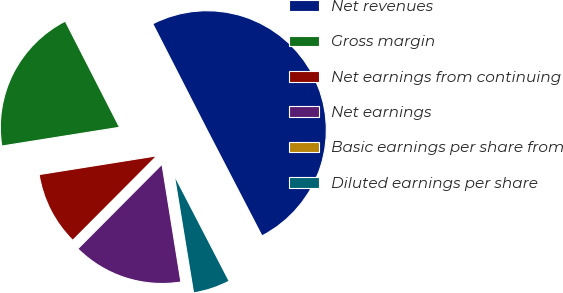Convert chart. <chart><loc_0><loc_0><loc_500><loc_500><pie_chart><fcel>Net revenues<fcel>Gross margin<fcel>Net earnings from continuing<fcel>Net earnings<fcel>Basic earnings per share from<fcel>Diluted earnings per share<nl><fcel>49.91%<fcel>19.99%<fcel>10.02%<fcel>15.0%<fcel>0.05%<fcel>5.03%<nl></chart> 